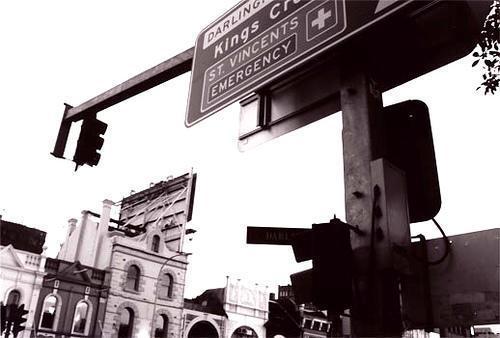How many complete windows can you see?
Give a very brief answer. 5. How many zebras are there altogether?
Give a very brief answer. 0. 